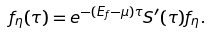<formula> <loc_0><loc_0><loc_500><loc_500>f _ { \eta } ( \tau ) = e ^ { - ( E _ { f } - \mu ) \tau } S ^ { \prime } ( \tau ) f _ { \eta } .</formula> 